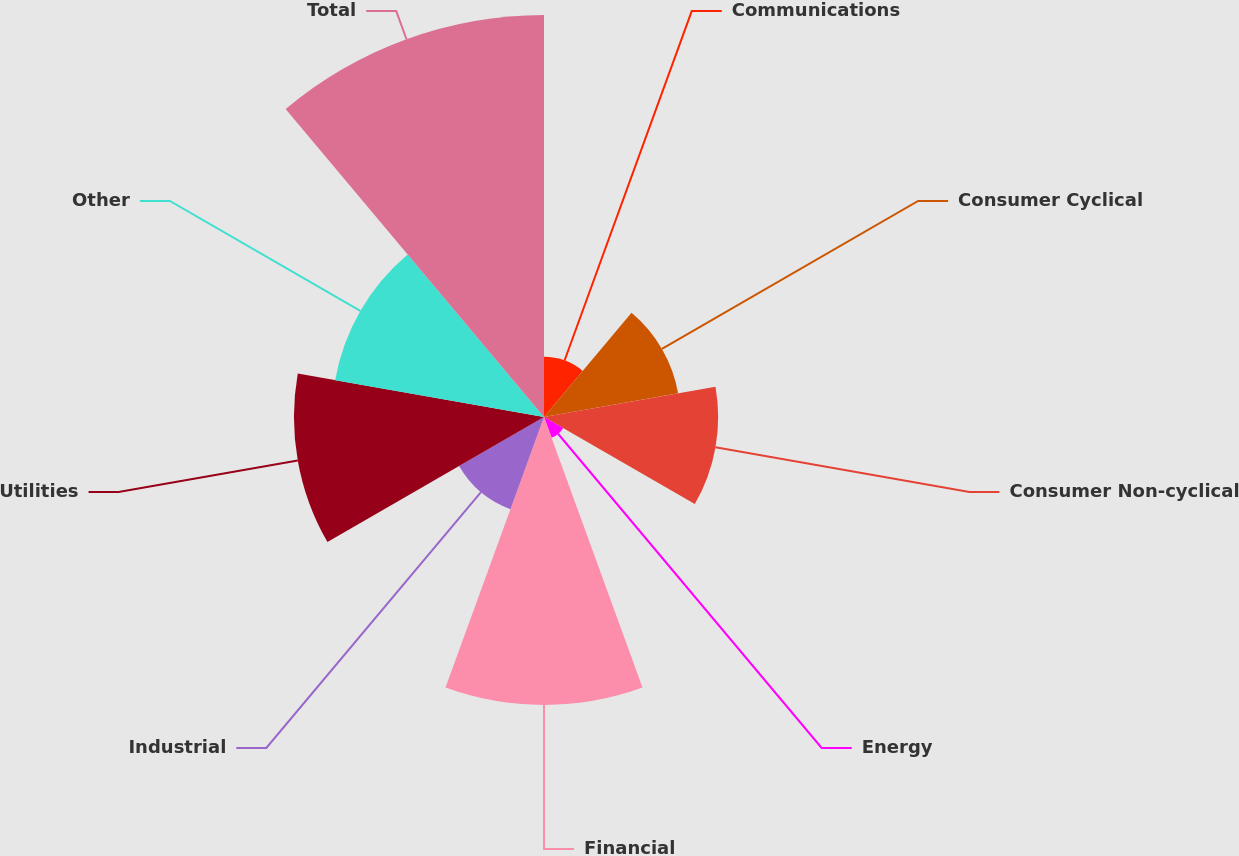<chart> <loc_0><loc_0><loc_500><loc_500><pie_chart><fcel>Communications<fcel>Consumer Cyclical<fcel>Consumer Non-cyclical<fcel>Energy<fcel>Financial<fcel>Industrial<fcel>Utilities<fcel>Other<fcel>Total<nl><fcel>3.66%<fcel>8.29%<fcel>10.6%<fcel>1.35%<fcel>17.53%<fcel>5.97%<fcel>15.22%<fcel>12.91%<fcel>24.47%<nl></chart> 